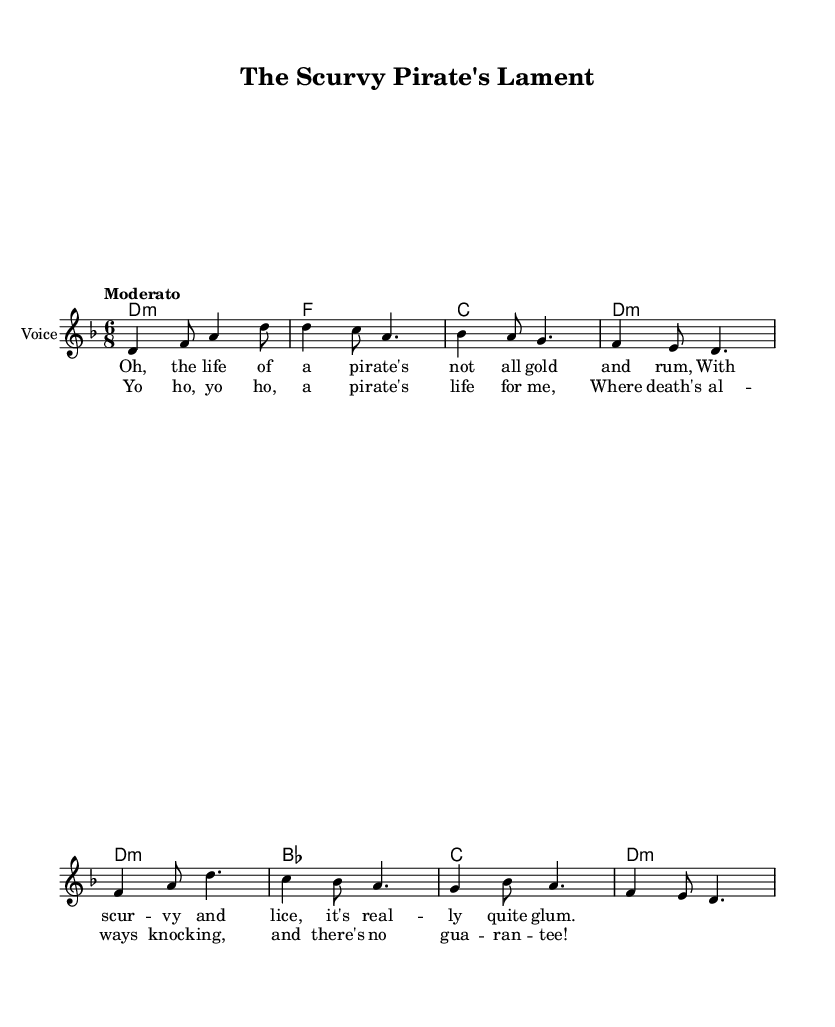What is the key signature of this music? The key signature is D minor, which is indicated by one flat (B♭) in the key signature area.
Answer: D minor What is the time signature of this music? The time signature is 6/8, which is displayed in the beginning of the score. It indicates there are six eighth notes per measure.
Answer: 6/8 What is the tempo marking for this piece? The tempo marking is "Moderato," which indicates a moderate speed for the performance of the piece.
Answer: Moderato How many measures are in the verse section? The verse consists of four measures, which can be counted from the notation of the melody line in the score.
Answer: 4 Which chord is played in the first measure? The chord played in the first measure is D minor, as indicated in the chord symbols above the staff.
Answer: D minor What is the lyrical theme of the song? The lyrical theme revolves around the hardships and grim realities of pirate life, as suggested by phrases like "scurvy and lice" and "death's always knocking."
Answer: Hardships of pirate life What is the refrain of this sea shanty? The refrain is "Yo ho, yo ho, a pirate's life for me, where death's always knocking, and there's no guarantee!" as repeated in the chorus section.
Answer: Yo ho, yo ho, a pirate's life for me 